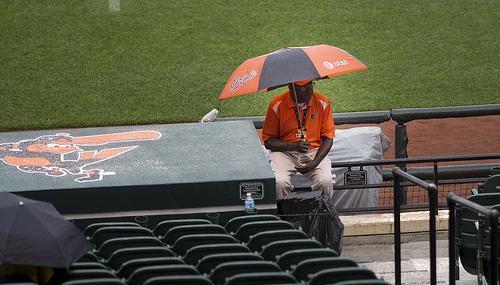How many people are in the photo?
Give a very brief answer. 1. 